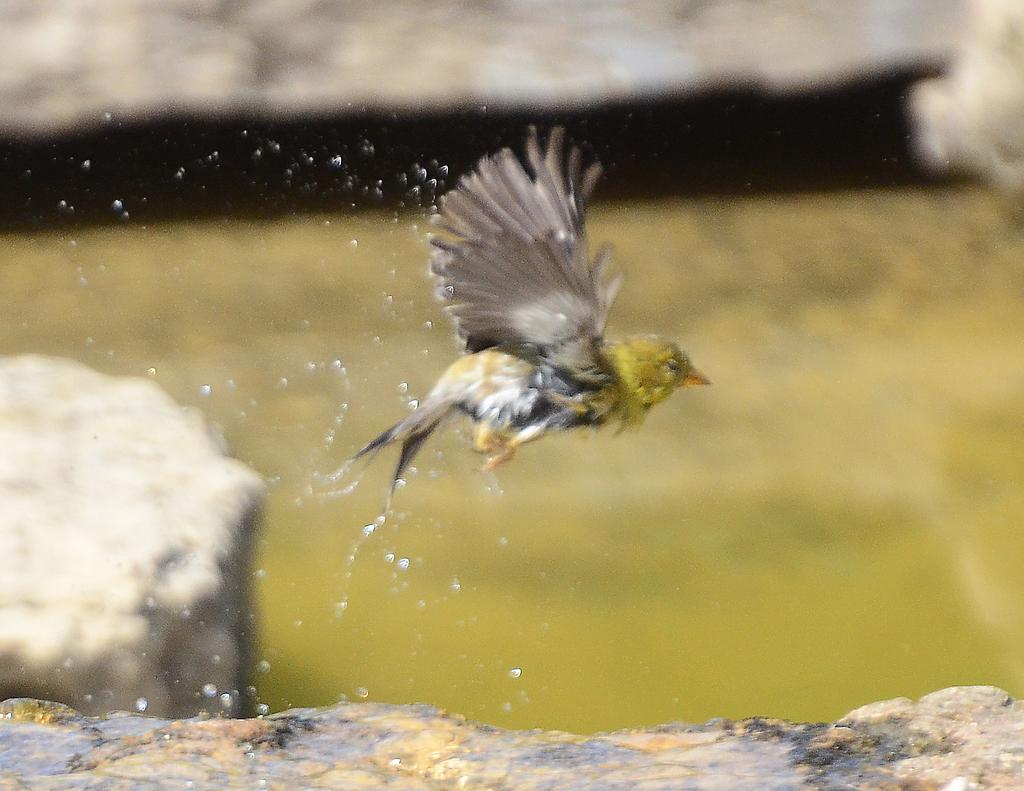What is the main subject of the image? There is a bird flying in the image. What else can be seen in the image besides the bird? Water droplets are visible in the image. How would you describe the background of the image? The background of the image is blurred. How many houses can be seen in the image? There are no houses present in the image; it features a bird flying and water droplets. What type of tramp is visible in the image? There is no tramp present in the image. 